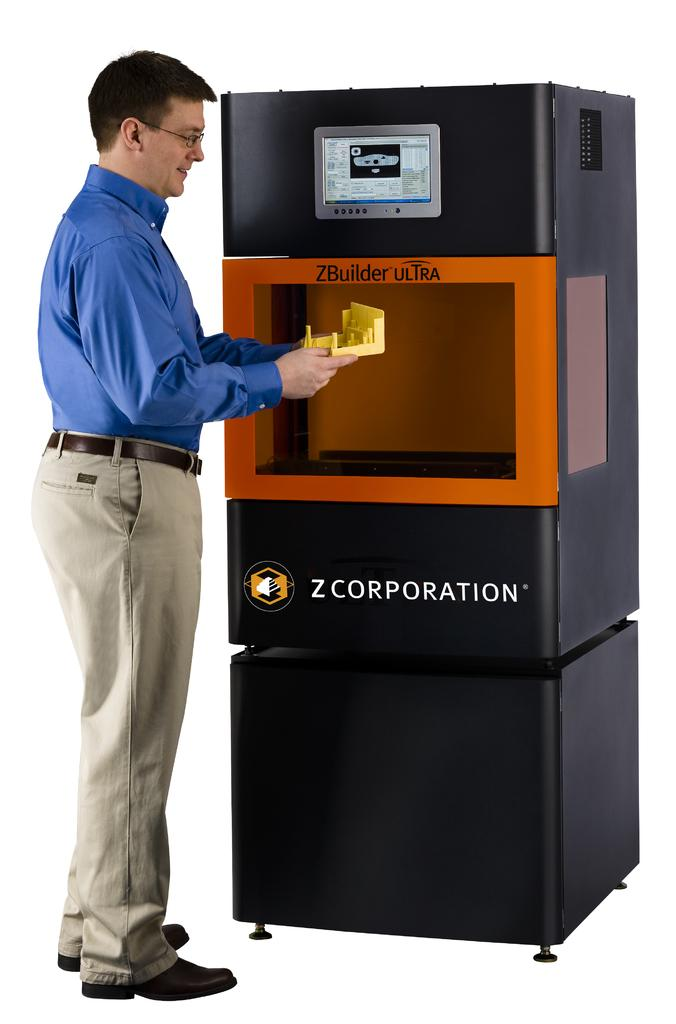<image>
Present a compact description of the photo's key features. A man is standing in front of a Z Corporation machine. 